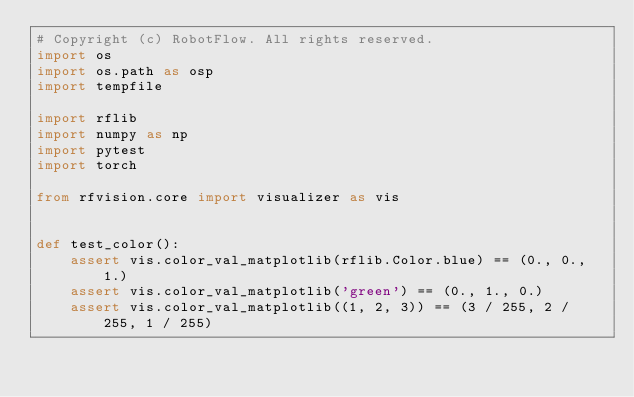<code> <loc_0><loc_0><loc_500><loc_500><_Python_># Copyright (c) RobotFlow. All rights reserved.
import os
import os.path as osp
import tempfile

import rflib
import numpy as np
import pytest
import torch

from rfvision.core import visualizer as vis


def test_color():
    assert vis.color_val_matplotlib(rflib.Color.blue) == (0., 0., 1.)
    assert vis.color_val_matplotlib('green') == (0., 1., 0.)
    assert vis.color_val_matplotlib((1, 2, 3)) == (3 / 255, 2 / 255, 1 / 255)</code> 